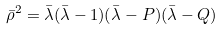<formula> <loc_0><loc_0><loc_500><loc_500>\bar { \rho } ^ { 2 } = \bar { \lambda } ( \bar { \lambda } - 1 ) ( \bar { \lambda } - P ) ( \bar { \lambda } - Q )</formula> 